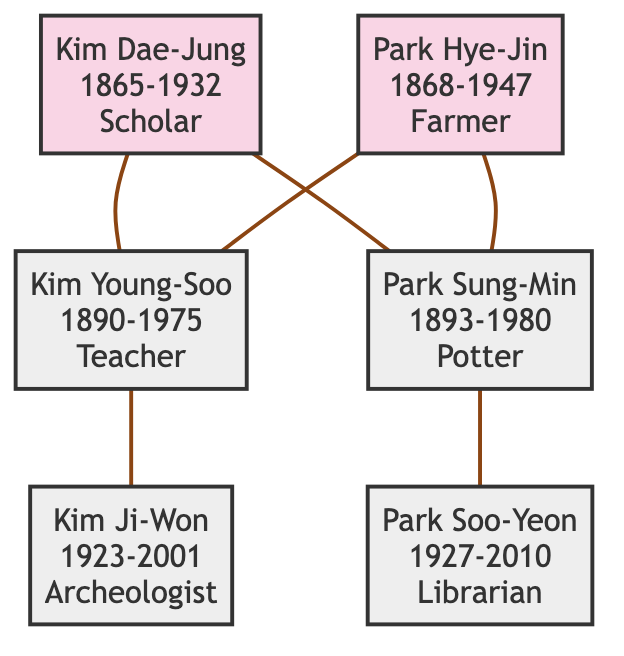What is the occupation of Kim Dae-Jung? In the diagram, Kim Dae-Jung's node indicates he was a Scholar. This is represented directly on his node in the family tree.
Answer: Scholar How many descendants does Kim Dae-Jung have? By examining the diagram, we can see Kim Dae-Jung is connected to two descendants: Kim Young-Soo and Park Sung-Min. Therefore, he has two descendants.
Answer: 2 Which ancestor is associated with farming? The diagram shows that Park Hye-Jin is labeled as a Farmer, which is mentioned directly on her node.
Answer: Park Hye-Jin What notable activity is associated with Kim Ji-Won? The node for Kim Ji-Won states he excavated significant artifacts in the Daereungwon Tomb Complex, making this his notable activity.
Answer: Excavated significant artifacts in the Daereungwon Tomb Complex Who is the descendant of both Kim Dae-Jung and Park Hye-Jin? If we trace the connections in the diagram, Kim Young-Soo is a descendant of both Kim Dae-Jung and Park Hye-Jin as he is connected to both ancestor nodes.
Answer: Kim Young-Soo How many ancestors are there in total? The family tree diagram displays two ancestors: Kim Dae-Jung and Park Hye-Jin. We count the nodes labeled as ancestors to arrive at this total.
Answer: 2 Which descendant managed ancient manuscripts? Park Soo-Yeon is identified as the Librarian on her node, and her notable activity states she managed ancient manuscripts at Gyeongju National Library.
Answer: Park Soo-Yeon Who lived the longest according to the diagram? By comparing the birth and death years of each individual in the diagram, Park Hye-Jin lived from 1868 to 1947, totaling 79 years, which is the longest among the listed individuals.
Answer: Park Hye-Jin What is the relationship between Park Sung-Min and Kim Ji-Won? The diagram indicates that Park Sung-Min (a descendant of Kim Dae-Jung) has a descendant relationship with Kim Ji-Won, as Park Sung-Min is connected to Kim Ji-Won as his child.
Answer: Sibling (or child) What year did Kim Young-Soo pass away? The node associated with Kim Young-Soo in the diagram clearly shows that he died in 1975.
Answer: 1975 